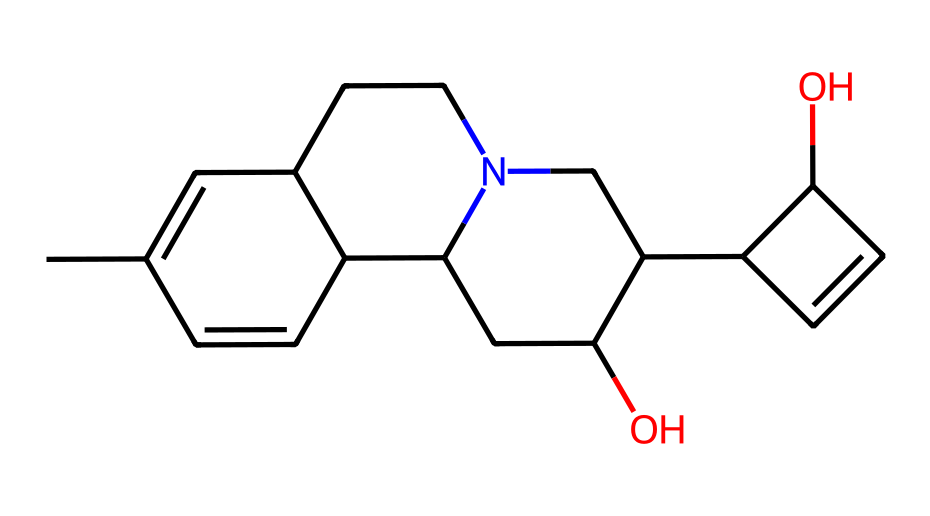How many carbon atoms are in quinine? To find the number of carbon atoms in the chemical structure represented by the SMILES, we count the "C" symbols in the SMILES string. In this case, there are 19 carbon atoms total.
Answer: 19 What type of functional groups are present in quinine? By analyzing the structure represented in the SMILES, we can identify that quinine contains an alcohol group (-OH) and nitrogen atoms, indicating it has both hydroxyl and amine functional groups.
Answer: hydroxyl and amine What is the molecular formula of quinine? The molecular formula can be derived from the counts of each type of atom identified in the SMILES. There are 19 carbon atoms, 22 hydrogen atoms, 1 nitrogen atom, and 1 oxygen atom, leading to the formula C19H22N2O.
Answer: C19H22N2O How many rings are there in the structure of quinine? In the SMILES representation, looking at the numbering involved indicates multiple fused rings present in the structure. After analysis, there are four rings in the overall structure of quinine.
Answer: 4 What element is primarily responsible for the pharmacological effects of quinine? The nitrogen atom in the structure is crucial for the pharmacological activity of alkaloids like quinine, which is responsible for its antimalarial properties.
Answer: nitrogen What aspect of quinine's structure contributes to its bitter taste? Alkaloids are known for their bitter taste, which can be attributed to the presence of the nitrogen atom in the molecular structure. The specific arrangement of carbon and nitrogen also plays a role.
Answer: nitrogen Which geographic region is the primary source of quinine? Quinine is historically extracted from cinchona trees, which are native to the Andes Mountains in South America, indicating its geographical origin.
Answer: Andes 